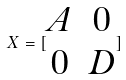<formula> <loc_0><loc_0><loc_500><loc_500>X = [ \begin{matrix} A & 0 \\ 0 & D \end{matrix} ]</formula> 